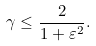<formula> <loc_0><loc_0><loc_500><loc_500>\gamma \leq \frac { 2 } { 1 + \varepsilon ^ { 2 } } .</formula> 